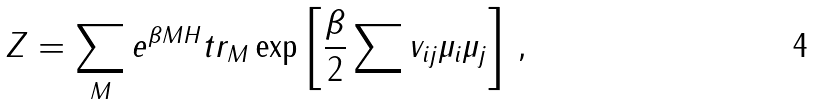Convert formula to latex. <formula><loc_0><loc_0><loc_500><loc_500>Z = \sum _ { M } e ^ { \beta M H } t r _ { M } \exp \left [ \frac { \beta } { 2 } \sum v _ { i j } \mu _ { i } \mu _ { j } \right ] \, ,</formula> 